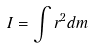Convert formula to latex. <formula><loc_0><loc_0><loc_500><loc_500>I = \int r ^ { 2 } d m</formula> 